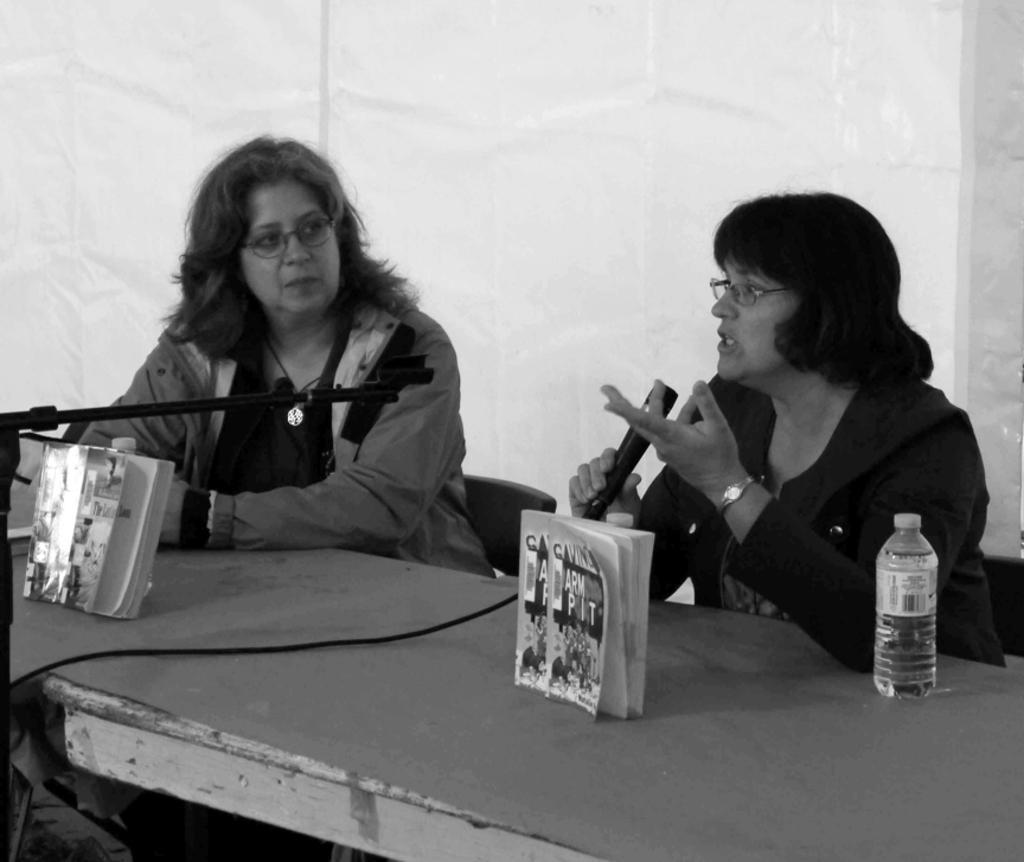Please provide a concise description of this image. It is a black and white picture there is a table and on the table there are two books and a bottle in front of the table there are two women sitting,the first woman is speaking from the mic and the woman beside her is paying attention to the first woman in the background there is a white color sheet. 